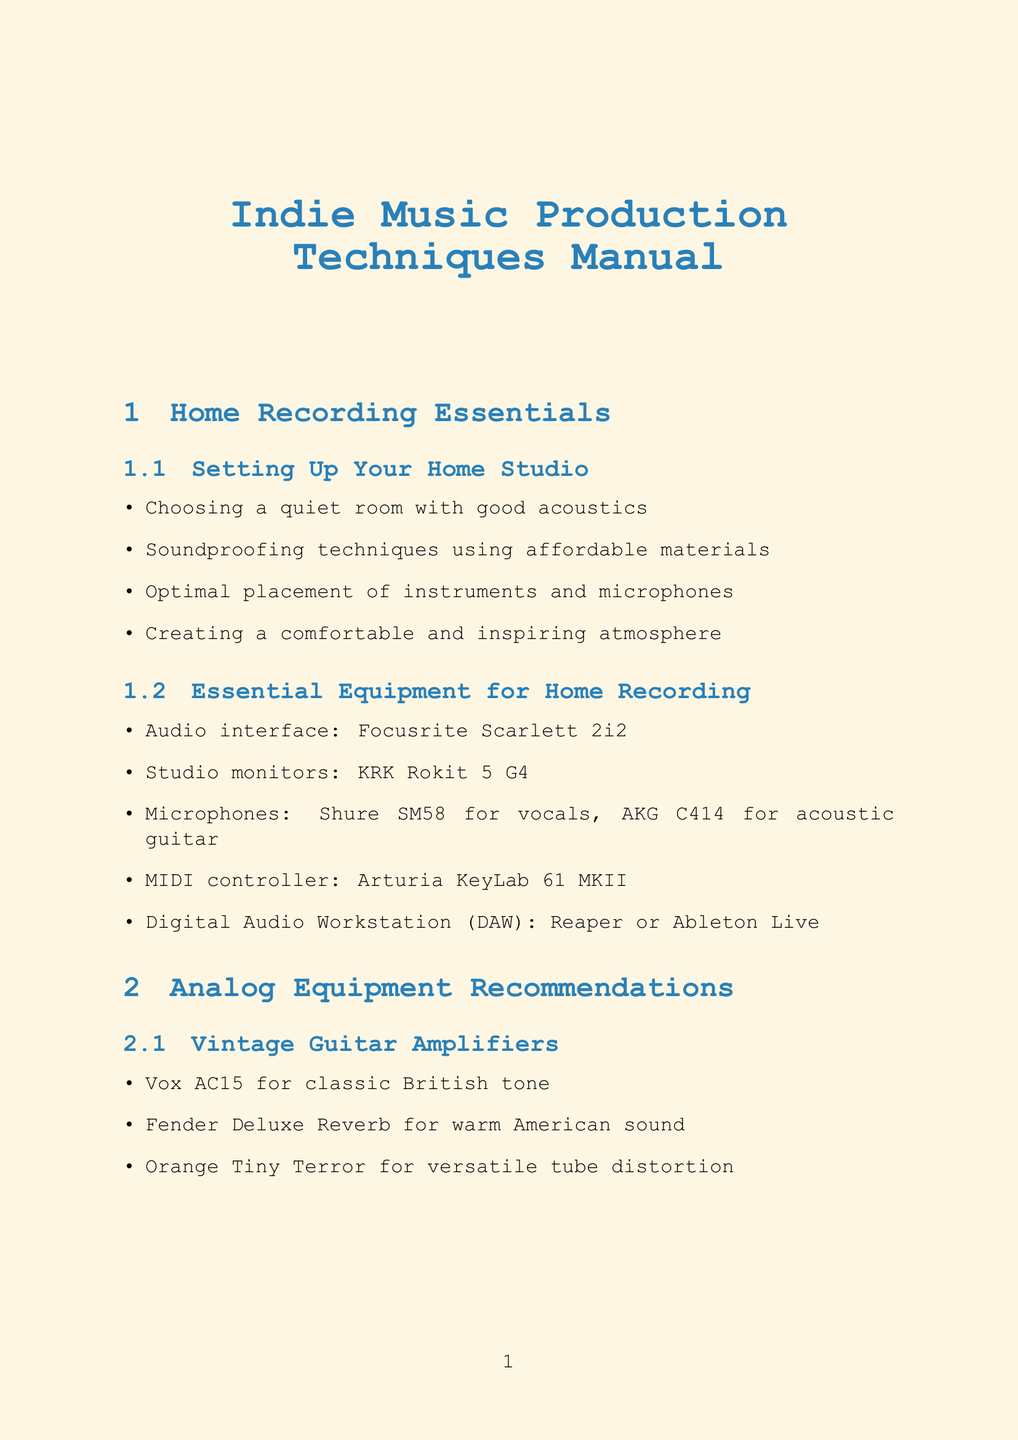What is the audio interface recommended for home recording? The document lists Focusrite Scarlett 2i2 as the audio interface recommended for home recording.
Answer: Focusrite Scarlett 2i2 Which vintage guitar amplifier is suggested for versatile tube distortion? The document mentions that the Orange Tiny Terror is recommended for versatile tube distortion.
Answer: Orange Tiny Terror What is the purpose of using subtractive EQ in mixing? According to the document, subtractive EQ is used to create space in the mix.
Answer: Create space What type of microphone is recommended for acoustic guitar? The AKG C414 is specified in the document as a recommended microphone for acoustic guitar.
Answer: AKG C414 How many types of analog effects pedals are mentioned in the document? The document lists four types of analog effects pedals, including overdrive, delay, reverb, and chorus.
Answer: Four What technique is suggested for achieving lo-fi sounds? The document suggests using tape saturation plugins like Waves J37 for achieving lo-fi sounds.
Answer: Tape saturation plugins What is one method to create stereo width with guitar tracks? The document indicates that creating stereo width can be achieved by using different guitar parts.
Answer: Different guitar parts How can one protect their work according to the licensing section? The document states that protecting work can be done with copyright registration.
Answer: Copyright registration 